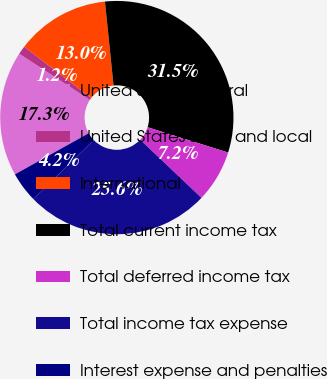<chart> <loc_0><loc_0><loc_500><loc_500><pie_chart><fcel>United States federal<fcel>United States state and local<fcel>International<fcel>Total current income tax<fcel>Total deferred income tax<fcel>Total income tax expense<fcel>Interest expense and penalties<nl><fcel>17.31%<fcel>1.18%<fcel>12.98%<fcel>31.47%<fcel>7.24%<fcel>25.62%<fcel>4.21%<nl></chart> 